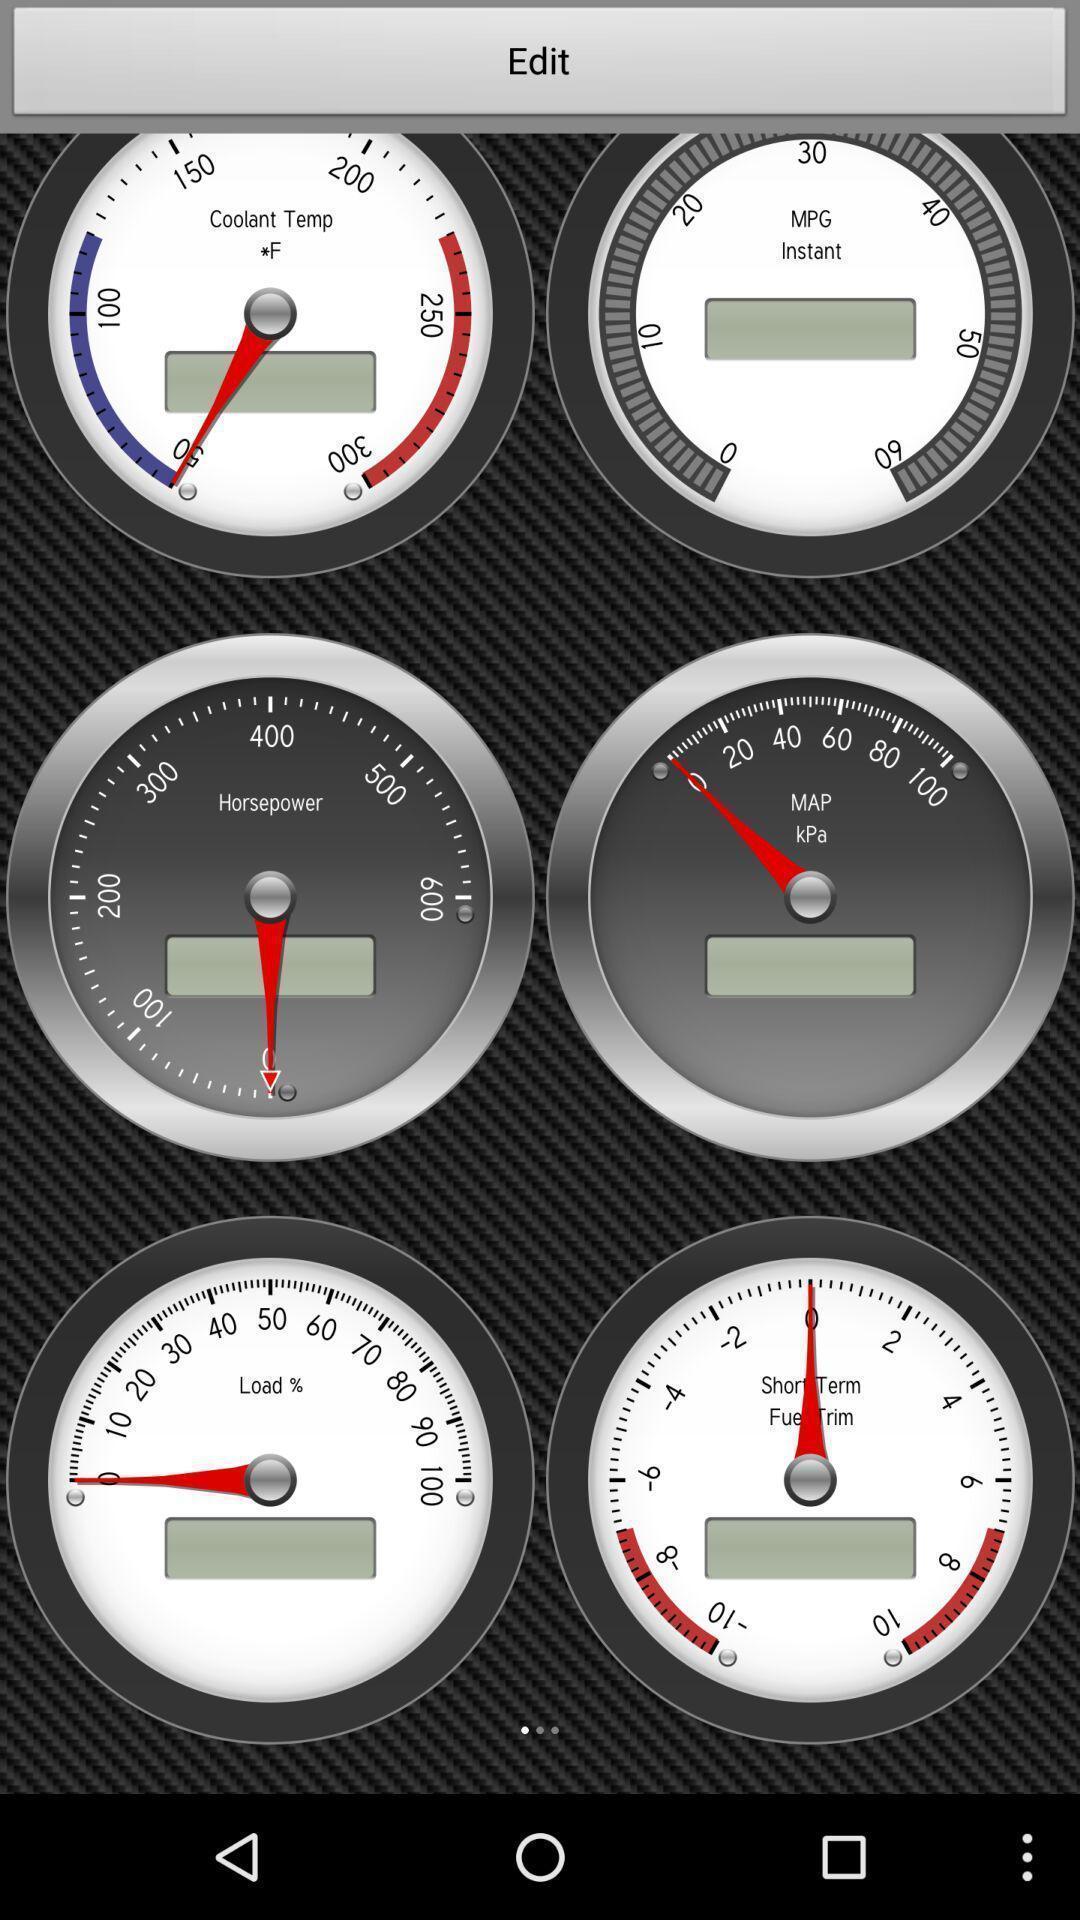Explain the elements present in this screenshot. Page displaying various images. 